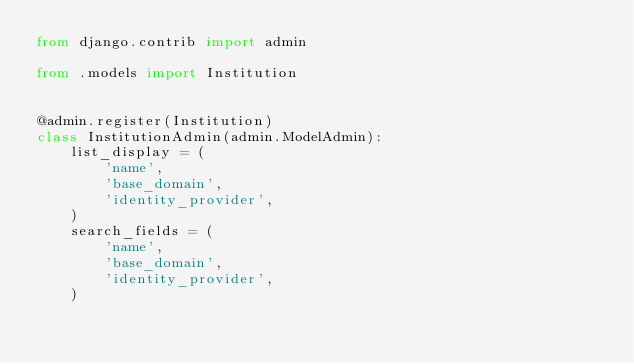<code> <loc_0><loc_0><loc_500><loc_500><_Python_>from django.contrib import admin

from .models import Institution


@admin.register(Institution)
class InstitutionAdmin(admin.ModelAdmin):
    list_display = (
        'name',
        'base_domain',
        'identity_provider',
    )
    search_fields = (
        'name',
        'base_domain',
        'identity_provider',
    )
</code> 